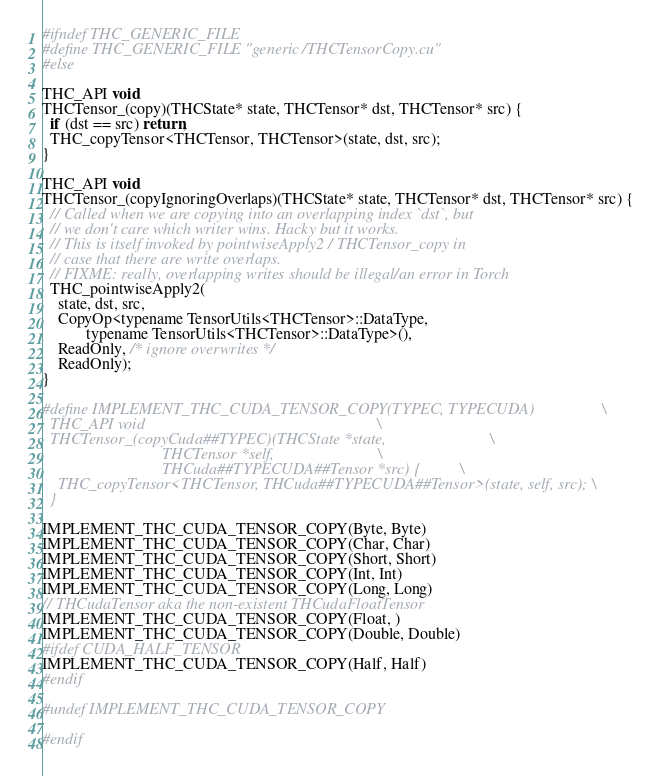Convert code to text. <code><loc_0><loc_0><loc_500><loc_500><_Cuda_>#ifndef THC_GENERIC_FILE
#define THC_GENERIC_FILE "generic/THCTensorCopy.cu"
#else

THC_API void
THCTensor_(copy)(THCState* state, THCTensor* dst, THCTensor* src) {
  if (dst == src) return;
  THC_copyTensor<THCTensor, THCTensor>(state, dst, src);
}

THC_API void
THCTensor_(copyIgnoringOverlaps)(THCState* state, THCTensor* dst, THCTensor* src) {
  // Called when we are copying into an overlapping index `dst`, but
  // we don't care which writer wins. Hacky but it works.
  // This is itself invoked by pointwiseApply2 / THCTensor_copy in
  // case that there are write overlaps.
  // FIXME: really, overlapping writes should be illegal/an error in Torch
  THC_pointwiseApply2(
    state, dst, src,
    CopyOp<typename TensorUtils<THCTensor>::DataType,
           typename TensorUtils<THCTensor>::DataType>(),
    ReadOnly, /* ignore overwrites */
    ReadOnly);
}

#define IMPLEMENT_THC_CUDA_TENSOR_COPY(TYPEC, TYPECUDA)                 \
  THC_API void                                                          \
  THCTensor_(copyCuda##TYPEC)(THCState *state,                          \
                              THCTensor *self,                          \
                              THCuda##TYPECUDA##Tensor *src) {          \
    THC_copyTensor<THCTensor, THCuda##TYPECUDA##Tensor>(state, self, src); \
  }

IMPLEMENT_THC_CUDA_TENSOR_COPY(Byte, Byte)
IMPLEMENT_THC_CUDA_TENSOR_COPY(Char, Char)
IMPLEMENT_THC_CUDA_TENSOR_COPY(Short, Short)
IMPLEMENT_THC_CUDA_TENSOR_COPY(Int, Int)
IMPLEMENT_THC_CUDA_TENSOR_COPY(Long, Long)
// THCudaTensor aka the non-existent THCudaFloatTensor
IMPLEMENT_THC_CUDA_TENSOR_COPY(Float, )
IMPLEMENT_THC_CUDA_TENSOR_COPY(Double, Double)
#ifdef CUDA_HALF_TENSOR
IMPLEMENT_THC_CUDA_TENSOR_COPY(Half, Half)
#endif

#undef IMPLEMENT_THC_CUDA_TENSOR_COPY

#endif
</code> 